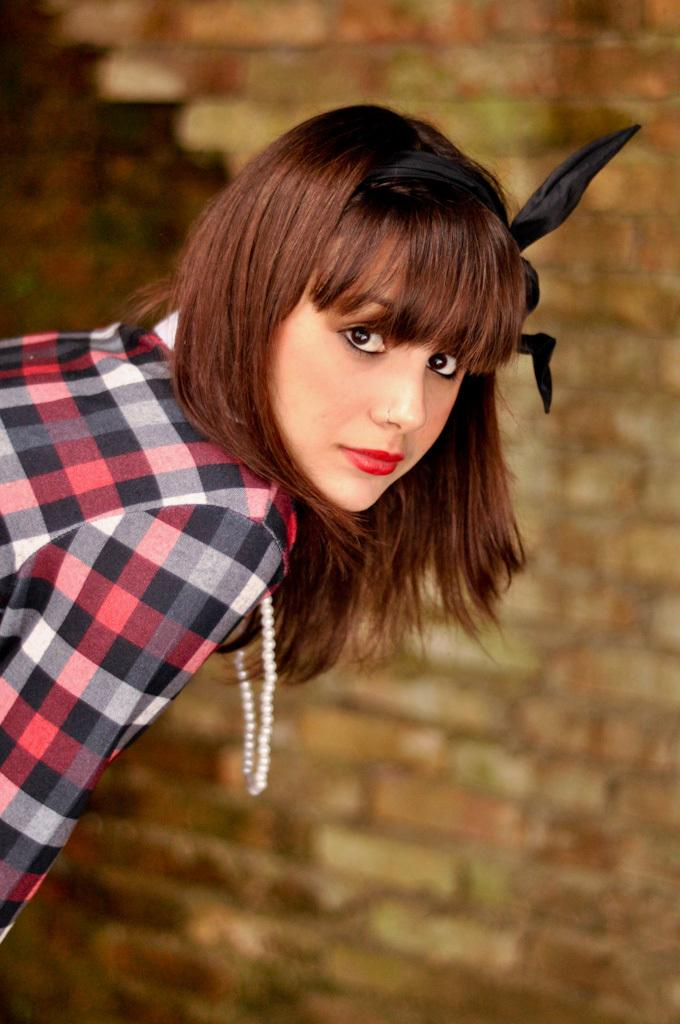Who is present in the image? There is a woman in the image. What is the woman wearing? The woman is wearing a shirt and a locket. What can be seen on the right side of the image? There is a brick wall on the right side of the image. What type of powder is being used by the woman in the image? There is no indication of any powder being used in the image. The woman is simply wearing a shirt and a locket, and there is a brick wall on the right side. 